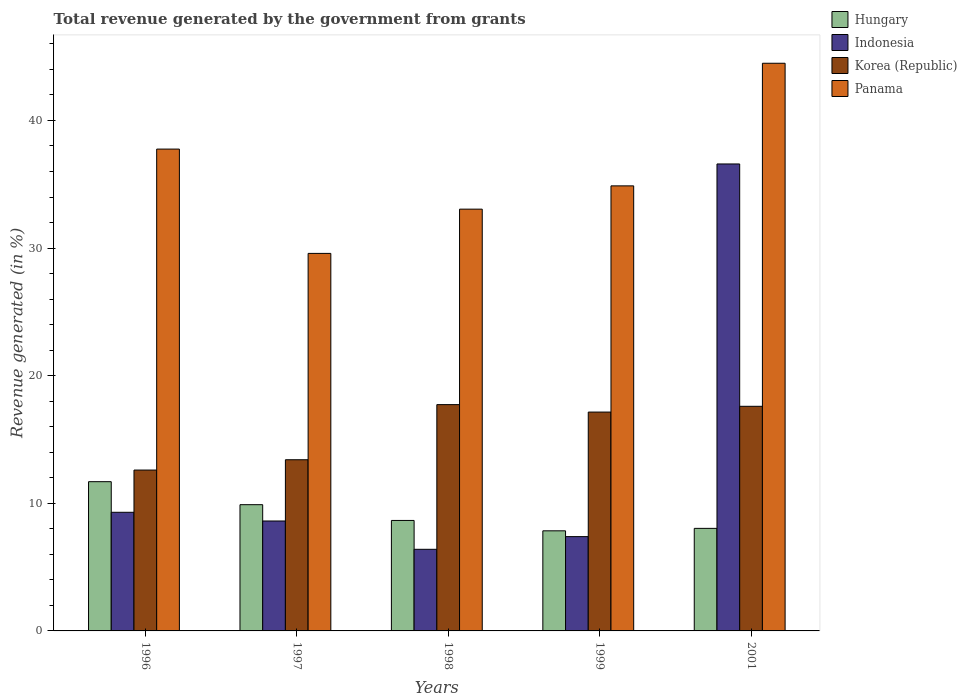Are the number of bars on each tick of the X-axis equal?
Make the answer very short. Yes. How many bars are there on the 2nd tick from the left?
Your response must be concise. 4. How many bars are there on the 5th tick from the right?
Offer a terse response. 4. What is the total revenue generated in Hungary in 2001?
Your answer should be very brief. 8.04. Across all years, what is the maximum total revenue generated in Korea (Republic)?
Give a very brief answer. 17.73. Across all years, what is the minimum total revenue generated in Korea (Republic)?
Your answer should be compact. 12.61. What is the total total revenue generated in Panama in the graph?
Ensure brevity in your answer.  179.75. What is the difference between the total revenue generated in Panama in 1996 and that in 1997?
Make the answer very short. 8.17. What is the difference between the total revenue generated in Hungary in 2001 and the total revenue generated in Korea (Republic) in 1999?
Give a very brief answer. -9.11. What is the average total revenue generated in Hungary per year?
Your answer should be very brief. 9.22. In the year 2001, what is the difference between the total revenue generated in Indonesia and total revenue generated in Korea (Republic)?
Make the answer very short. 18.99. In how many years, is the total revenue generated in Korea (Republic) greater than 18 %?
Keep it short and to the point. 0. What is the ratio of the total revenue generated in Indonesia in 1997 to that in 2001?
Give a very brief answer. 0.24. What is the difference between the highest and the second highest total revenue generated in Panama?
Provide a short and direct response. 6.73. What is the difference between the highest and the lowest total revenue generated in Panama?
Your answer should be very brief. 14.9. In how many years, is the total revenue generated in Korea (Republic) greater than the average total revenue generated in Korea (Republic) taken over all years?
Your response must be concise. 3. What does the 1st bar from the left in 1996 represents?
Offer a very short reply. Hungary. What does the 4th bar from the right in 1998 represents?
Provide a succinct answer. Hungary. Are all the bars in the graph horizontal?
Your answer should be compact. No. How many years are there in the graph?
Keep it short and to the point. 5. What is the difference between two consecutive major ticks on the Y-axis?
Your response must be concise. 10. Does the graph contain any zero values?
Offer a very short reply. No. Does the graph contain grids?
Your answer should be compact. No. Where does the legend appear in the graph?
Offer a terse response. Top right. How are the legend labels stacked?
Your answer should be compact. Vertical. What is the title of the graph?
Keep it short and to the point. Total revenue generated by the government from grants. Does "Guinea-Bissau" appear as one of the legend labels in the graph?
Keep it short and to the point. No. What is the label or title of the Y-axis?
Keep it short and to the point. Revenue generated (in %). What is the Revenue generated (in %) of Hungary in 1996?
Give a very brief answer. 11.69. What is the Revenue generated (in %) in Indonesia in 1996?
Keep it short and to the point. 9.3. What is the Revenue generated (in %) in Korea (Republic) in 1996?
Provide a succinct answer. 12.61. What is the Revenue generated (in %) in Panama in 1996?
Your answer should be very brief. 37.76. What is the Revenue generated (in %) of Hungary in 1997?
Offer a very short reply. 9.89. What is the Revenue generated (in %) in Indonesia in 1997?
Offer a very short reply. 8.61. What is the Revenue generated (in %) in Korea (Republic) in 1997?
Offer a very short reply. 13.41. What is the Revenue generated (in %) in Panama in 1997?
Make the answer very short. 29.58. What is the Revenue generated (in %) in Hungary in 1998?
Make the answer very short. 8.66. What is the Revenue generated (in %) of Indonesia in 1998?
Your answer should be very brief. 6.4. What is the Revenue generated (in %) in Korea (Republic) in 1998?
Offer a very short reply. 17.73. What is the Revenue generated (in %) in Panama in 1998?
Your answer should be compact. 33.05. What is the Revenue generated (in %) of Hungary in 1999?
Offer a terse response. 7.84. What is the Revenue generated (in %) in Indonesia in 1999?
Provide a succinct answer. 7.39. What is the Revenue generated (in %) of Korea (Republic) in 1999?
Keep it short and to the point. 17.15. What is the Revenue generated (in %) of Panama in 1999?
Provide a short and direct response. 34.88. What is the Revenue generated (in %) of Hungary in 2001?
Your answer should be very brief. 8.04. What is the Revenue generated (in %) of Indonesia in 2001?
Your answer should be very brief. 36.59. What is the Revenue generated (in %) in Korea (Republic) in 2001?
Provide a short and direct response. 17.6. What is the Revenue generated (in %) in Panama in 2001?
Make the answer very short. 44.48. Across all years, what is the maximum Revenue generated (in %) of Hungary?
Ensure brevity in your answer.  11.69. Across all years, what is the maximum Revenue generated (in %) in Indonesia?
Make the answer very short. 36.59. Across all years, what is the maximum Revenue generated (in %) in Korea (Republic)?
Make the answer very short. 17.73. Across all years, what is the maximum Revenue generated (in %) of Panama?
Offer a terse response. 44.48. Across all years, what is the minimum Revenue generated (in %) of Hungary?
Offer a terse response. 7.84. Across all years, what is the minimum Revenue generated (in %) in Indonesia?
Offer a terse response. 6.4. Across all years, what is the minimum Revenue generated (in %) of Korea (Republic)?
Keep it short and to the point. 12.61. Across all years, what is the minimum Revenue generated (in %) of Panama?
Ensure brevity in your answer.  29.58. What is the total Revenue generated (in %) in Hungary in the graph?
Ensure brevity in your answer.  46.12. What is the total Revenue generated (in %) of Indonesia in the graph?
Keep it short and to the point. 68.29. What is the total Revenue generated (in %) in Korea (Republic) in the graph?
Provide a short and direct response. 78.5. What is the total Revenue generated (in %) in Panama in the graph?
Keep it short and to the point. 179.75. What is the difference between the Revenue generated (in %) of Hungary in 1996 and that in 1997?
Provide a short and direct response. 1.8. What is the difference between the Revenue generated (in %) of Indonesia in 1996 and that in 1997?
Make the answer very short. 0.68. What is the difference between the Revenue generated (in %) in Korea (Republic) in 1996 and that in 1997?
Offer a very short reply. -0.81. What is the difference between the Revenue generated (in %) of Panama in 1996 and that in 1997?
Ensure brevity in your answer.  8.17. What is the difference between the Revenue generated (in %) in Hungary in 1996 and that in 1998?
Make the answer very short. 3.04. What is the difference between the Revenue generated (in %) of Indonesia in 1996 and that in 1998?
Your answer should be compact. 2.9. What is the difference between the Revenue generated (in %) of Korea (Republic) in 1996 and that in 1998?
Ensure brevity in your answer.  -5.13. What is the difference between the Revenue generated (in %) of Panama in 1996 and that in 1998?
Your answer should be compact. 4.71. What is the difference between the Revenue generated (in %) of Hungary in 1996 and that in 1999?
Provide a succinct answer. 3.85. What is the difference between the Revenue generated (in %) of Indonesia in 1996 and that in 1999?
Ensure brevity in your answer.  1.91. What is the difference between the Revenue generated (in %) of Korea (Republic) in 1996 and that in 1999?
Your answer should be compact. -4.54. What is the difference between the Revenue generated (in %) in Panama in 1996 and that in 1999?
Keep it short and to the point. 2.88. What is the difference between the Revenue generated (in %) in Hungary in 1996 and that in 2001?
Your answer should be compact. 3.66. What is the difference between the Revenue generated (in %) of Indonesia in 1996 and that in 2001?
Ensure brevity in your answer.  -27.3. What is the difference between the Revenue generated (in %) in Korea (Republic) in 1996 and that in 2001?
Give a very brief answer. -5. What is the difference between the Revenue generated (in %) in Panama in 1996 and that in 2001?
Your response must be concise. -6.73. What is the difference between the Revenue generated (in %) in Hungary in 1997 and that in 1998?
Offer a very short reply. 1.24. What is the difference between the Revenue generated (in %) in Indonesia in 1997 and that in 1998?
Offer a terse response. 2.22. What is the difference between the Revenue generated (in %) of Korea (Republic) in 1997 and that in 1998?
Your response must be concise. -4.32. What is the difference between the Revenue generated (in %) of Panama in 1997 and that in 1998?
Your answer should be compact. -3.47. What is the difference between the Revenue generated (in %) of Hungary in 1997 and that in 1999?
Provide a succinct answer. 2.05. What is the difference between the Revenue generated (in %) in Indonesia in 1997 and that in 1999?
Give a very brief answer. 1.22. What is the difference between the Revenue generated (in %) of Korea (Republic) in 1997 and that in 1999?
Your answer should be compact. -3.74. What is the difference between the Revenue generated (in %) of Panama in 1997 and that in 1999?
Ensure brevity in your answer.  -5.29. What is the difference between the Revenue generated (in %) in Hungary in 1997 and that in 2001?
Provide a succinct answer. 1.86. What is the difference between the Revenue generated (in %) in Indonesia in 1997 and that in 2001?
Ensure brevity in your answer.  -27.98. What is the difference between the Revenue generated (in %) of Korea (Republic) in 1997 and that in 2001?
Keep it short and to the point. -4.19. What is the difference between the Revenue generated (in %) of Panama in 1997 and that in 2001?
Provide a succinct answer. -14.9. What is the difference between the Revenue generated (in %) in Hungary in 1998 and that in 1999?
Your response must be concise. 0.81. What is the difference between the Revenue generated (in %) in Indonesia in 1998 and that in 1999?
Offer a terse response. -0.99. What is the difference between the Revenue generated (in %) in Korea (Republic) in 1998 and that in 1999?
Your response must be concise. 0.58. What is the difference between the Revenue generated (in %) in Panama in 1998 and that in 1999?
Make the answer very short. -1.82. What is the difference between the Revenue generated (in %) in Hungary in 1998 and that in 2001?
Provide a short and direct response. 0.62. What is the difference between the Revenue generated (in %) in Indonesia in 1998 and that in 2001?
Your answer should be very brief. -30.2. What is the difference between the Revenue generated (in %) of Korea (Republic) in 1998 and that in 2001?
Offer a very short reply. 0.13. What is the difference between the Revenue generated (in %) in Panama in 1998 and that in 2001?
Make the answer very short. -11.43. What is the difference between the Revenue generated (in %) in Hungary in 1999 and that in 2001?
Make the answer very short. -0.19. What is the difference between the Revenue generated (in %) in Indonesia in 1999 and that in 2001?
Keep it short and to the point. -29.2. What is the difference between the Revenue generated (in %) in Korea (Republic) in 1999 and that in 2001?
Offer a terse response. -0.45. What is the difference between the Revenue generated (in %) of Panama in 1999 and that in 2001?
Your response must be concise. -9.61. What is the difference between the Revenue generated (in %) in Hungary in 1996 and the Revenue generated (in %) in Indonesia in 1997?
Provide a succinct answer. 3.08. What is the difference between the Revenue generated (in %) in Hungary in 1996 and the Revenue generated (in %) in Korea (Republic) in 1997?
Offer a terse response. -1.72. What is the difference between the Revenue generated (in %) of Hungary in 1996 and the Revenue generated (in %) of Panama in 1997?
Offer a terse response. -17.89. What is the difference between the Revenue generated (in %) in Indonesia in 1996 and the Revenue generated (in %) in Korea (Republic) in 1997?
Offer a terse response. -4.12. What is the difference between the Revenue generated (in %) in Indonesia in 1996 and the Revenue generated (in %) in Panama in 1997?
Give a very brief answer. -20.29. What is the difference between the Revenue generated (in %) in Korea (Republic) in 1996 and the Revenue generated (in %) in Panama in 1997?
Offer a terse response. -16.98. What is the difference between the Revenue generated (in %) of Hungary in 1996 and the Revenue generated (in %) of Indonesia in 1998?
Your answer should be compact. 5.3. What is the difference between the Revenue generated (in %) in Hungary in 1996 and the Revenue generated (in %) in Korea (Republic) in 1998?
Offer a very short reply. -6.04. What is the difference between the Revenue generated (in %) of Hungary in 1996 and the Revenue generated (in %) of Panama in 1998?
Your answer should be compact. -21.36. What is the difference between the Revenue generated (in %) in Indonesia in 1996 and the Revenue generated (in %) in Korea (Republic) in 1998?
Your answer should be very brief. -8.44. What is the difference between the Revenue generated (in %) of Indonesia in 1996 and the Revenue generated (in %) of Panama in 1998?
Make the answer very short. -23.75. What is the difference between the Revenue generated (in %) of Korea (Republic) in 1996 and the Revenue generated (in %) of Panama in 1998?
Your response must be concise. -20.44. What is the difference between the Revenue generated (in %) of Hungary in 1996 and the Revenue generated (in %) of Indonesia in 1999?
Offer a very short reply. 4.3. What is the difference between the Revenue generated (in %) in Hungary in 1996 and the Revenue generated (in %) in Korea (Republic) in 1999?
Provide a short and direct response. -5.46. What is the difference between the Revenue generated (in %) of Hungary in 1996 and the Revenue generated (in %) of Panama in 1999?
Ensure brevity in your answer.  -23.18. What is the difference between the Revenue generated (in %) of Indonesia in 1996 and the Revenue generated (in %) of Korea (Republic) in 1999?
Offer a very short reply. -7.85. What is the difference between the Revenue generated (in %) in Indonesia in 1996 and the Revenue generated (in %) in Panama in 1999?
Keep it short and to the point. -25.58. What is the difference between the Revenue generated (in %) in Korea (Republic) in 1996 and the Revenue generated (in %) in Panama in 1999?
Your response must be concise. -22.27. What is the difference between the Revenue generated (in %) of Hungary in 1996 and the Revenue generated (in %) of Indonesia in 2001?
Your answer should be very brief. -24.9. What is the difference between the Revenue generated (in %) of Hungary in 1996 and the Revenue generated (in %) of Korea (Republic) in 2001?
Your answer should be very brief. -5.91. What is the difference between the Revenue generated (in %) in Hungary in 1996 and the Revenue generated (in %) in Panama in 2001?
Offer a terse response. -32.79. What is the difference between the Revenue generated (in %) in Indonesia in 1996 and the Revenue generated (in %) in Korea (Republic) in 2001?
Make the answer very short. -8.3. What is the difference between the Revenue generated (in %) of Indonesia in 1996 and the Revenue generated (in %) of Panama in 2001?
Provide a short and direct response. -35.19. What is the difference between the Revenue generated (in %) in Korea (Republic) in 1996 and the Revenue generated (in %) in Panama in 2001?
Provide a succinct answer. -31.88. What is the difference between the Revenue generated (in %) in Hungary in 1997 and the Revenue generated (in %) in Indonesia in 1998?
Offer a terse response. 3.5. What is the difference between the Revenue generated (in %) in Hungary in 1997 and the Revenue generated (in %) in Korea (Republic) in 1998?
Keep it short and to the point. -7.84. What is the difference between the Revenue generated (in %) in Hungary in 1997 and the Revenue generated (in %) in Panama in 1998?
Offer a terse response. -23.16. What is the difference between the Revenue generated (in %) in Indonesia in 1997 and the Revenue generated (in %) in Korea (Republic) in 1998?
Your answer should be very brief. -9.12. What is the difference between the Revenue generated (in %) in Indonesia in 1997 and the Revenue generated (in %) in Panama in 1998?
Your response must be concise. -24.44. What is the difference between the Revenue generated (in %) of Korea (Republic) in 1997 and the Revenue generated (in %) of Panama in 1998?
Your answer should be compact. -19.64. What is the difference between the Revenue generated (in %) in Hungary in 1997 and the Revenue generated (in %) in Indonesia in 1999?
Make the answer very short. 2.5. What is the difference between the Revenue generated (in %) in Hungary in 1997 and the Revenue generated (in %) in Korea (Republic) in 1999?
Your answer should be compact. -7.26. What is the difference between the Revenue generated (in %) in Hungary in 1997 and the Revenue generated (in %) in Panama in 1999?
Offer a very short reply. -24.98. What is the difference between the Revenue generated (in %) of Indonesia in 1997 and the Revenue generated (in %) of Korea (Republic) in 1999?
Offer a terse response. -8.54. What is the difference between the Revenue generated (in %) in Indonesia in 1997 and the Revenue generated (in %) in Panama in 1999?
Ensure brevity in your answer.  -26.26. What is the difference between the Revenue generated (in %) in Korea (Republic) in 1997 and the Revenue generated (in %) in Panama in 1999?
Make the answer very short. -21.46. What is the difference between the Revenue generated (in %) in Hungary in 1997 and the Revenue generated (in %) in Indonesia in 2001?
Your answer should be very brief. -26.7. What is the difference between the Revenue generated (in %) in Hungary in 1997 and the Revenue generated (in %) in Korea (Republic) in 2001?
Offer a terse response. -7.71. What is the difference between the Revenue generated (in %) of Hungary in 1997 and the Revenue generated (in %) of Panama in 2001?
Provide a succinct answer. -34.59. What is the difference between the Revenue generated (in %) of Indonesia in 1997 and the Revenue generated (in %) of Korea (Republic) in 2001?
Your answer should be very brief. -8.99. What is the difference between the Revenue generated (in %) of Indonesia in 1997 and the Revenue generated (in %) of Panama in 2001?
Your answer should be compact. -35.87. What is the difference between the Revenue generated (in %) in Korea (Republic) in 1997 and the Revenue generated (in %) in Panama in 2001?
Make the answer very short. -31.07. What is the difference between the Revenue generated (in %) in Hungary in 1998 and the Revenue generated (in %) in Indonesia in 1999?
Offer a terse response. 1.27. What is the difference between the Revenue generated (in %) of Hungary in 1998 and the Revenue generated (in %) of Korea (Republic) in 1999?
Ensure brevity in your answer.  -8.49. What is the difference between the Revenue generated (in %) in Hungary in 1998 and the Revenue generated (in %) in Panama in 1999?
Your answer should be very brief. -26.22. What is the difference between the Revenue generated (in %) in Indonesia in 1998 and the Revenue generated (in %) in Korea (Republic) in 1999?
Give a very brief answer. -10.75. What is the difference between the Revenue generated (in %) of Indonesia in 1998 and the Revenue generated (in %) of Panama in 1999?
Your answer should be compact. -28.48. What is the difference between the Revenue generated (in %) in Korea (Republic) in 1998 and the Revenue generated (in %) in Panama in 1999?
Your answer should be compact. -17.14. What is the difference between the Revenue generated (in %) in Hungary in 1998 and the Revenue generated (in %) in Indonesia in 2001?
Your answer should be very brief. -27.94. What is the difference between the Revenue generated (in %) in Hungary in 1998 and the Revenue generated (in %) in Korea (Republic) in 2001?
Keep it short and to the point. -8.94. What is the difference between the Revenue generated (in %) in Hungary in 1998 and the Revenue generated (in %) in Panama in 2001?
Give a very brief answer. -35.83. What is the difference between the Revenue generated (in %) in Indonesia in 1998 and the Revenue generated (in %) in Korea (Republic) in 2001?
Provide a succinct answer. -11.2. What is the difference between the Revenue generated (in %) of Indonesia in 1998 and the Revenue generated (in %) of Panama in 2001?
Ensure brevity in your answer.  -38.09. What is the difference between the Revenue generated (in %) of Korea (Republic) in 1998 and the Revenue generated (in %) of Panama in 2001?
Your answer should be very brief. -26.75. What is the difference between the Revenue generated (in %) of Hungary in 1999 and the Revenue generated (in %) of Indonesia in 2001?
Offer a terse response. -28.75. What is the difference between the Revenue generated (in %) in Hungary in 1999 and the Revenue generated (in %) in Korea (Republic) in 2001?
Your answer should be compact. -9.76. What is the difference between the Revenue generated (in %) in Hungary in 1999 and the Revenue generated (in %) in Panama in 2001?
Offer a very short reply. -36.64. What is the difference between the Revenue generated (in %) of Indonesia in 1999 and the Revenue generated (in %) of Korea (Republic) in 2001?
Provide a short and direct response. -10.21. What is the difference between the Revenue generated (in %) of Indonesia in 1999 and the Revenue generated (in %) of Panama in 2001?
Keep it short and to the point. -37.09. What is the difference between the Revenue generated (in %) in Korea (Republic) in 1999 and the Revenue generated (in %) in Panama in 2001?
Provide a succinct answer. -27.33. What is the average Revenue generated (in %) of Hungary per year?
Ensure brevity in your answer.  9.22. What is the average Revenue generated (in %) in Indonesia per year?
Provide a short and direct response. 13.66. What is the average Revenue generated (in %) in Korea (Republic) per year?
Your answer should be compact. 15.7. What is the average Revenue generated (in %) in Panama per year?
Your answer should be compact. 35.95. In the year 1996, what is the difference between the Revenue generated (in %) in Hungary and Revenue generated (in %) in Indonesia?
Make the answer very short. 2.4. In the year 1996, what is the difference between the Revenue generated (in %) in Hungary and Revenue generated (in %) in Korea (Republic)?
Keep it short and to the point. -0.91. In the year 1996, what is the difference between the Revenue generated (in %) in Hungary and Revenue generated (in %) in Panama?
Ensure brevity in your answer.  -26.06. In the year 1996, what is the difference between the Revenue generated (in %) of Indonesia and Revenue generated (in %) of Korea (Republic)?
Provide a short and direct response. -3.31. In the year 1996, what is the difference between the Revenue generated (in %) in Indonesia and Revenue generated (in %) in Panama?
Provide a succinct answer. -28.46. In the year 1996, what is the difference between the Revenue generated (in %) in Korea (Republic) and Revenue generated (in %) in Panama?
Give a very brief answer. -25.15. In the year 1997, what is the difference between the Revenue generated (in %) in Hungary and Revenue generated (in %) in Indonesia?
Offer a terse response. 1.28. In the year 1997, what is the difference between the Revenue generated (in %) of Hungary and Revenue generated (in %) of Korea (Republic)?
Make the answer very short. -3.52. In the year 1997, what is the difference between the Revenue generated (in %) in Hungary and Revenue generated (in %) in Panama?
Your answer should be very brief. -19.69. In the year 1997, what is the difference between the Revenue generated (in %) of Indonesia and Revenue generated (in %) of Korea (Republic)?
Your answer should be compact. -4.8. In the year 1997, what is the difference between the Revenue generated (in %) in Indonesia and Revenue generated (in %) in Panama?
Make the answer very short. -20.97. In the year 1997, what is the difference between the Revenue generated (in %) in Korea (Republic) and Revenue generated (in %) in Panama?
Ensure brevity in your answer.  -16.17. In the year 1998, what is the difference between the Revenue generated (in %) in Hungary and Revenue generated (in %) in Indonesia?
Offer a very short reply. 2.26. In the year 1998, what is the difference between the Revenue generated (in %) in Hungary and Revenue generated (in %) in Korea (Republic)?
Offer a very short reply. -9.08. In the year 1998, what is the difference between the Revenue generated (in %) in Hungary and Revenue generated (in %) in Panama?
Offer a terse response. -24.39. In the year 1998, what is the difference between the Revenue generated (in %) of Indonesia and Revenue generated (in %) of Korea (Republic)?
Offer a very short reply. -11.34. In the year 1998, what is the difference between the Revenue generated (in %) in Indonesia and Revenue generated (in %) in Panama?
Keep it short and to the point. -26.65. In the year 1998, what is the difference between the Revenue generated (in %) of Korea (Republic) and Revenue generated (in %) of Panama?
Your answer should be very brief. -15.32. In the year 1999, what is the difference between the Revenue generated (in %) of Hungary and Revenue generated (in %) of Indonesia?
Give a very brief answer. 0.45. In the year 1999, what is the difference between the Revenue generated (in %) in Hungary and Revenue generated (in %) in Korea (Republic)?
Your answer should be compact. -9.31. In the year 1999, what is the difference between the Revenue generated (in %) of Hungary and Revenue generated (in %) of Panama?
Your answer should be compact. -27.03. In the year 1999, what is the difference between the Revenue generated (in %) of Indonesia and Revenue generated (in %) of Korea (Republic)?
Offer a terse response. -9.76. In the year 1999, what is the difference between the Revenue generated (in %) of Indonesia and Revenue generated (in %) of Panama?
Provide a short and direct response. -27.49. In the year 1999, what is the difference between the Revenue generated (in %) in Korea (Republic) and Revenue generated (in %) in Panama?
Your answer should be very brief. -17.72. In the year 2001, what is the difference between the Revenue generated (in %) of Hungary and Revenue generated (in %) of Indonesia?
Your answer should be very brief. -28.56. In the year 2001, what is the difference between the Revenue generated (in %) of Hungary and Revenue generated (in %) of Korea (Republic)?
Your answer should be very brief. -9.56. In the year 2001, what is the difference between the Revenue generated (in %) in Hungary and Revenue generated (in %) in Panama?
Provide a short and direct response. -36.45. In the year 2001, what is the difference between the Revenue generated (in %) of Indonesia and Revenue generated (in %) of Korea (Republic)?
Offer a terse response. 18.99. In the year 2001, what is the difference between the Revenue generated (in %) of Indonesia and Revenue generated (in %) of Panama?
Your answer should be very brief. -7.89. In the year 2001, what is the difference between the Revenue generated (in %) in Korea (Republic) and Revenue generated (in %) in Panama?
Keep it short and to the point. -26.88. What is the ratio of the Revenue generated (in %) of Hungary in 1996 to that in 1997?
Offer a terse response. 1.18. What is the ratio of the Revenue generated (in %) in Indonesia in 1996 to that in 1997?
Give a very brief answer. 1.08. What is the ratio of the Revenue generated (in %) in Korea (Republic) in 1996 to that in 1997?
Your answer should be very brief. 0.94. What is the ratio of the Revenue generated (in %) in Panama in 1996 to that in 1997?
Keep it short and to the point. 1.28. What is the ratio of the Revenue generated (in %) in Hungary in 1996 to that in 1998?
Offer a very short reply. 1.35. What is the ratio of the Revenue generated (in %) of Indonesia in 1996 to that in 1998?
Provide a short and direct response. 1.45. What is the ratio of the Revenue generated (in %) in Korea (Republic) in 1996 to that in 1998?
Provide a succinct answer. 0.71. What is the ratio of the Revenue generated (in %) of Panama in 1996 to that in 1998?
Your answer should be very brief. 1.14. What is the ratio of the Revenue generated (in %) in Hungary in 1996 to that in 1999?
Your response must be concise. 1.49. What is the ratio of the Revenue generated (in %) of Indonesia in 1996 to that in 1999?
Your answer should be compact. 1.26. What is the ratio of the Revenue generated (in %) in Korea (Republic) in 1996 to that in 1999?
Your response must be concise. 0.73. What is the ratio of the Revenue generated (in %) of Panama in 1996 to that in 1999?
Your answer should be very brief. 1.08. What is the ratio of the Revenue generated (in %) of Hungary in 1996 to that in 2001?
Your response must be concise. 1.46. What is the ratio of the Revenue generated (in %) in Indonesia in 1996 to that in 2001?
Ensure brevity in your answer.  0.25. What is the ratio of the Revenue generated (in %) in Korea (Republic) in 1996 to that in 2001?
Make the answer very short. 0.72. What is the ratio of the Revenue generated (in %) in Panama in 1996 to that in 2001?
Make the answer very short. 0.85. What is the ratio of the Revenue generated (in %) of Hungary in 1997 to that in 1998?
Your response must be concise. 1.14. What is the ratio of the Revenue generated (in %) of Indonesia in 1997 to that in 1998?
Offer a terse response. 1.35. What is the ratio of the Revenue generated (in %) in Korea (Republic) in 1997 to that in 1998?
Offer a terse response. 0.76. What is the ratio of the Revenue generated (in %) of Panama in 1997 to that in 1998?
Offer a terse response. 0.9. What is the ratio of the Revenue generated (in %) in Hungary in 1997 to that in 1999?
Provide a succinct answer. 1.26. What is the ratio of the Revenue generated (in %) in Indonesia in 1997 to that in 1999?
Keep it short and to the point. 1.17. What is the ratio of the Revenue generated (in %) of Korea (Republic) in 1997 to that in 1999?
Your answer should be very brief. 0.78. What is the ratio of the Revenue generated (in %) in Panama in 1997 to that in 1999?
Your answer should be compact. 0.85. What is the ratio of the Revenue generated (in %) in Hungary in 1997 to that in 2001?
Keep it short and to the point. 1.23. What is the ratio of the Revenue generated (in %) in Indonesia in 1997 to that in 2001?
Your answer should be compact. 0.24. What is the ratio of the Revenue generated (in %) of Korea (Republic) in 1997 to that in 2001?
Your response must be concise. 0.76. What is the ratio of the Revenue generated (in %) in Panama in 1997 to that in 2001?
Provide a short and direct response. 0.67. What is the ratio of the Revenue generated (in %) of Hungary in 1998 to that in 1999?
Ensure brevity in your answer.  1.1. What is the ratio of the Revenue generated (in %) of Indonesia in 1998 to that in 1999?
Offer a terse response. 0.87. What is the ratio of the Revenue generated (in %) of Korea (Republic) in 1998 to that in 1999?
Your answer should be very brief. 1.03. What is the ratio of the Revenue generated (in %) in Panama in 1998 to that in 1999?
Keep it short and to the point. 0.95. What is the ratio of the Revenue generated (in %) of Hungary in 1998 to that in 2001?
Ensure brevity in your answer.  1.08. What is the ratio of the Revenue generated (in %) in Indonesia in 1998 to that in 2001?
Your answer should be very brief. 0.17. What is the ratio of the Revenue generated (in %) of Korea (Republic) in 1998 to that in 2001?
Make the answer very short. 1.01. What is the ratio of the Revenue generated (in %) of Panama in 1998 to that in 2001?
Make the answer very short. 0.74. What is the ratio of the Revenue generated (in %) of Hungary in 1999 to that in 2001?
Your response must be concise. 0.98. What is the ratio of the Revenue generated (in %) of Indonesia in 1999 to that in 2001?
Keep it short and to the point. 0.2. What is the ratio of the Revenue generated (in %) in Korea (Republic) in 1999 to that in 2001?
Give a very brief answer. 0.97. What is the ratio of the Revenue generated (in %) in Panama in 1999 to that in 2001?
Your answer should be very brief. 0.78. What is the difference between the highest and the second highest Revenue generated (in %) in Hungary?
Your answer should be compact. 1.8. What is the difference between the highest and the second highest Revenue generated (in %) of Indonesia?
Provide a short and direct response. 27.3. What is the difference between the highest and the second highest Revenue generated (in %) of Korea (Republic)?
Your answer should be compact. 0.13. What is the difference between the highest and the second highest Revenue generated (in %) of Panama?
Offer a terse response. 6.73. What is the difference between the highest and the lowest Revenue generated (in %) of Hungary?
Ensure brevity in your answer.  3.85. What is the difference between the highest and the lowest Revenue generated (in %) in Indonesia?
Make the answer very short. 30.2. What is the difference between the highest and the lowest Revenue generated (in %) of Korea (Republic)?
Give a very brief answer. 5.13. 